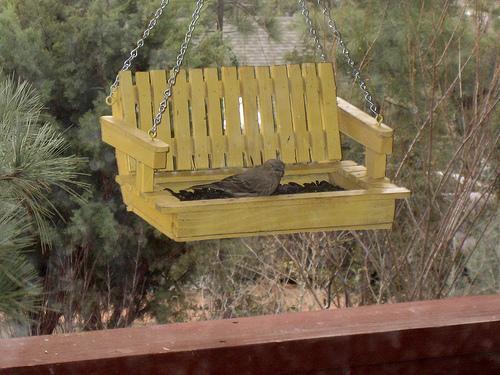How many birds are in the picture?
Give a very brief answer. 1. 